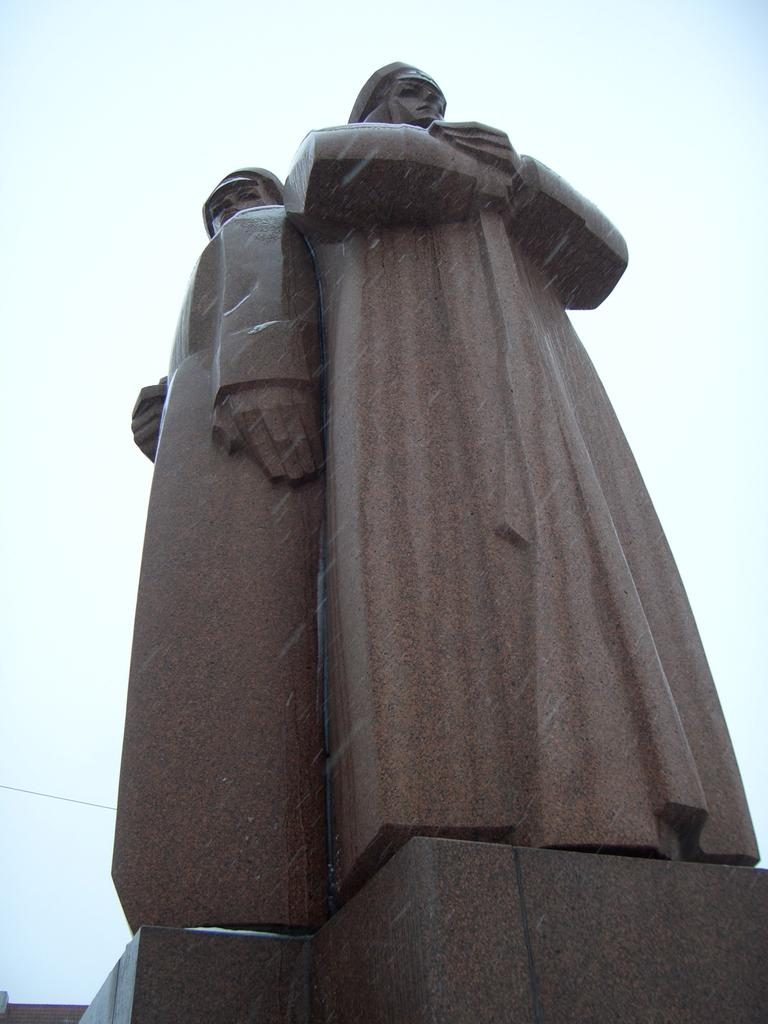What is the main subject in the center of the image? There is a statue in the center of the image. Are there any additional features on the statue? Yes, there is a wire visible on the backside of the statue. What can be seen in the background of the image? The sky is visible in the image. How would you describe the weather based on the sky? The sky appears to be cloudy. What type of soda is being poured from the statue in the image? There is no soda present in the image; it features a statue with a wire on its backside and a cloudy sky in the background. 